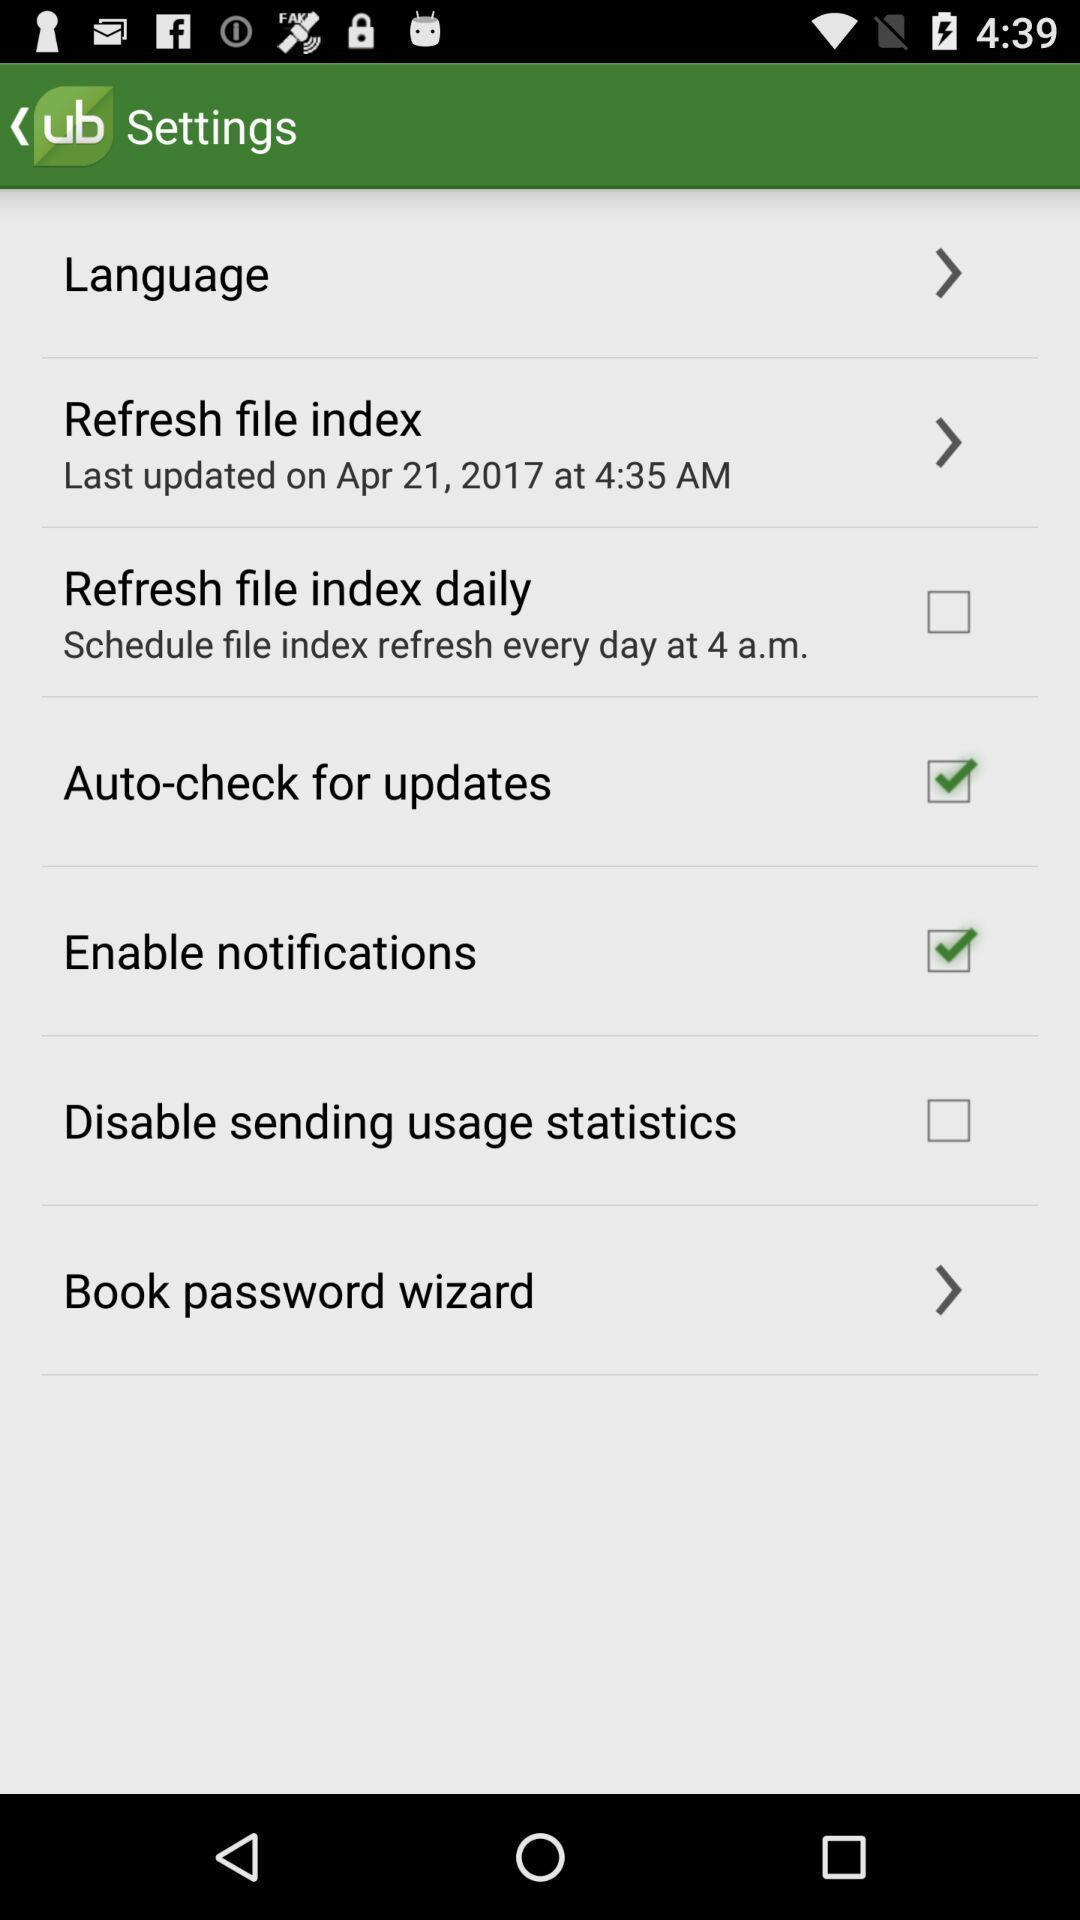Describe the key features of this screenshot. Settings page. 